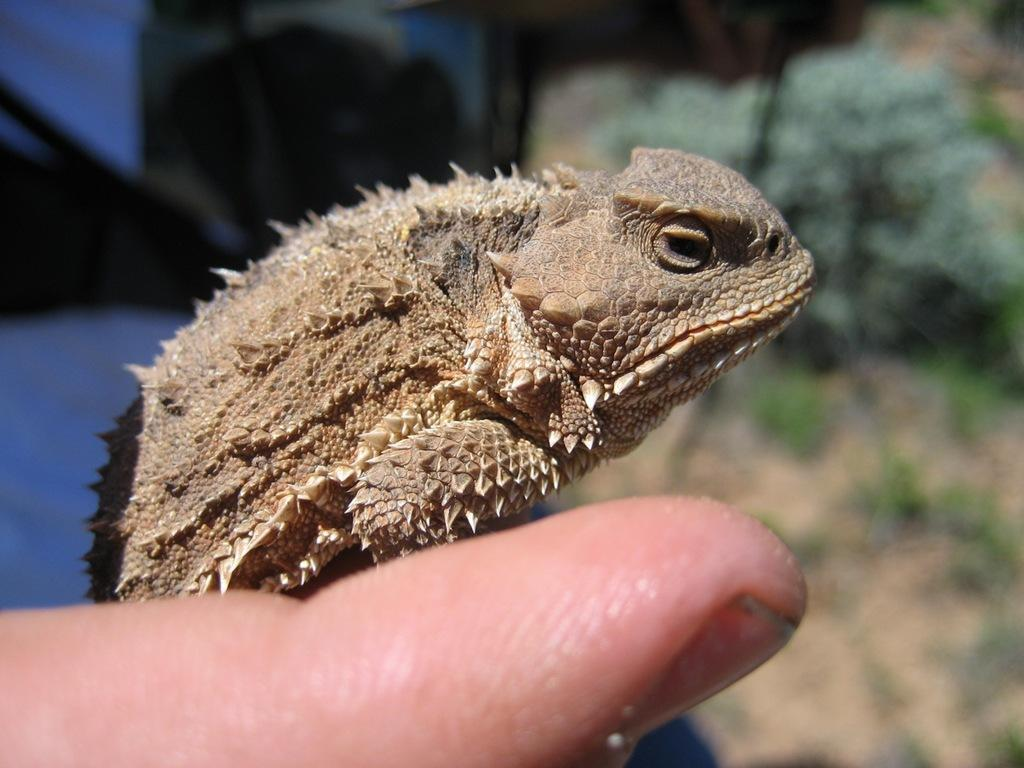What type of animal is in the image? There is a chameleon in the image. Where is the chameleon located? The chameleon is sitting on the hand of a person. What type of dirt can be seen on the girl's quarter in the image? There is no girl or quarter present in the image; it features a chameleon sitting on a person's hand. 